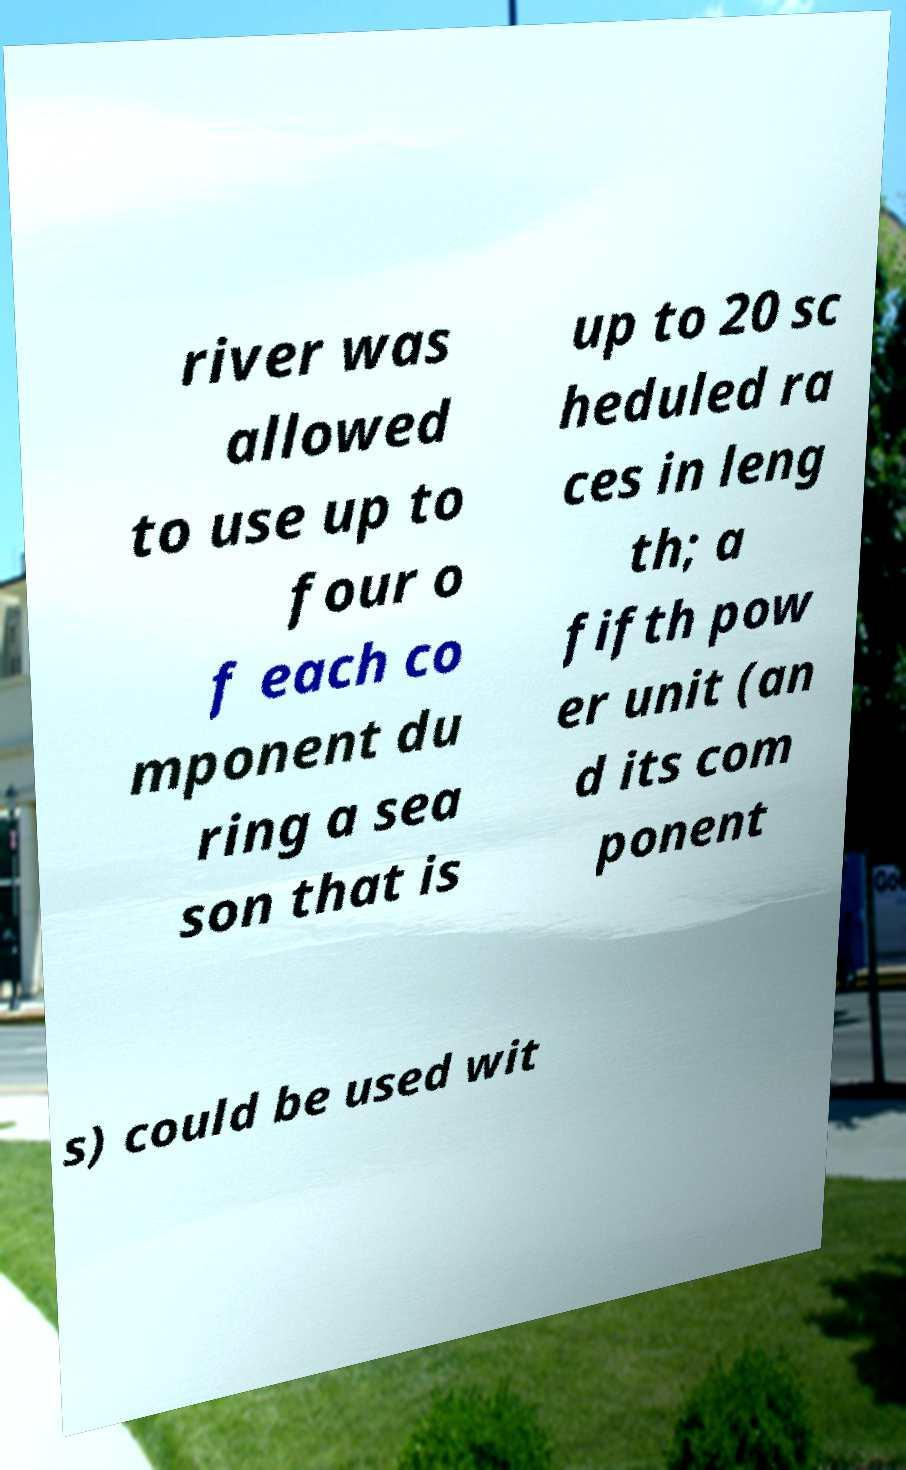Could you extract and type out the text from this image? river was allowed to use up to four o f each co mponent du ring a sea son that is up to 20 sc heduled ra ces in leng th; a fifth pow er unit (an d its com ponent s) could be used wit 